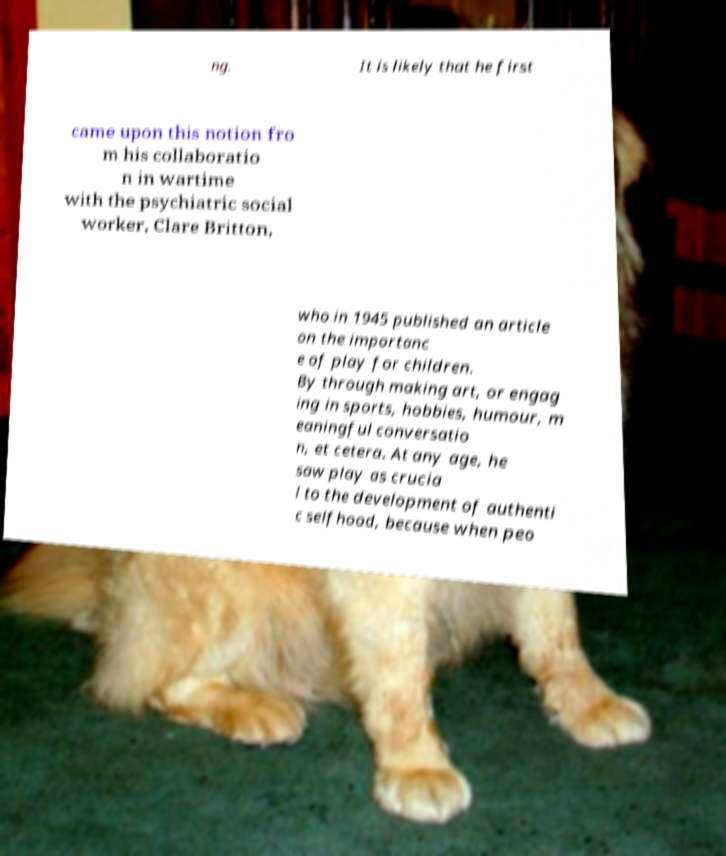Could you extract and type out the text from this image? ng. It is likely that he first came upon this notion fro m his collaboratio n in wartime with the psychiatric social worker, Clare Britton, who in 1945 published an article on the importanc e of play for children. By through making art, or engag ing in sports, hobbies, humour, m eaningful conversatio n, et cetera. At any age, he saw play as crucia l to the development of authenti c selfhood, because when peo 